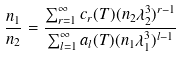<formula> <loc_0><loc_0><loc_500><loc_500>\frac { n _ { 1 } } { n _ { 2 } } = \frac { \sum _ { r = 1 } ^ { \infty } c _ { r } ( T ) ( n _ { 2 } \lambda _ { 2 } ^ { 3 } ) ^ { r - 1 } } { \sum _ { l = 1 } ^ { \infty } a _ { l } ( T ) ( n _ { 1 } \lambda _ { 1 } ^ { 3 } ) ^ { l - 1 } }</formula> 